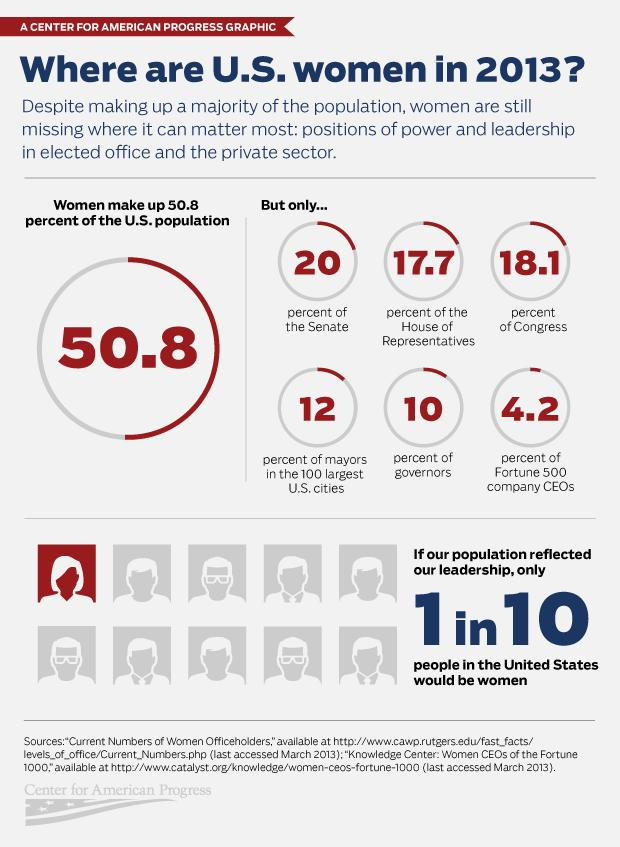Indicate a few pertinent items in this graphic. In 2013, approximately 20% of Senators were women. In 2013, it was found that only 10% of governors were women. 